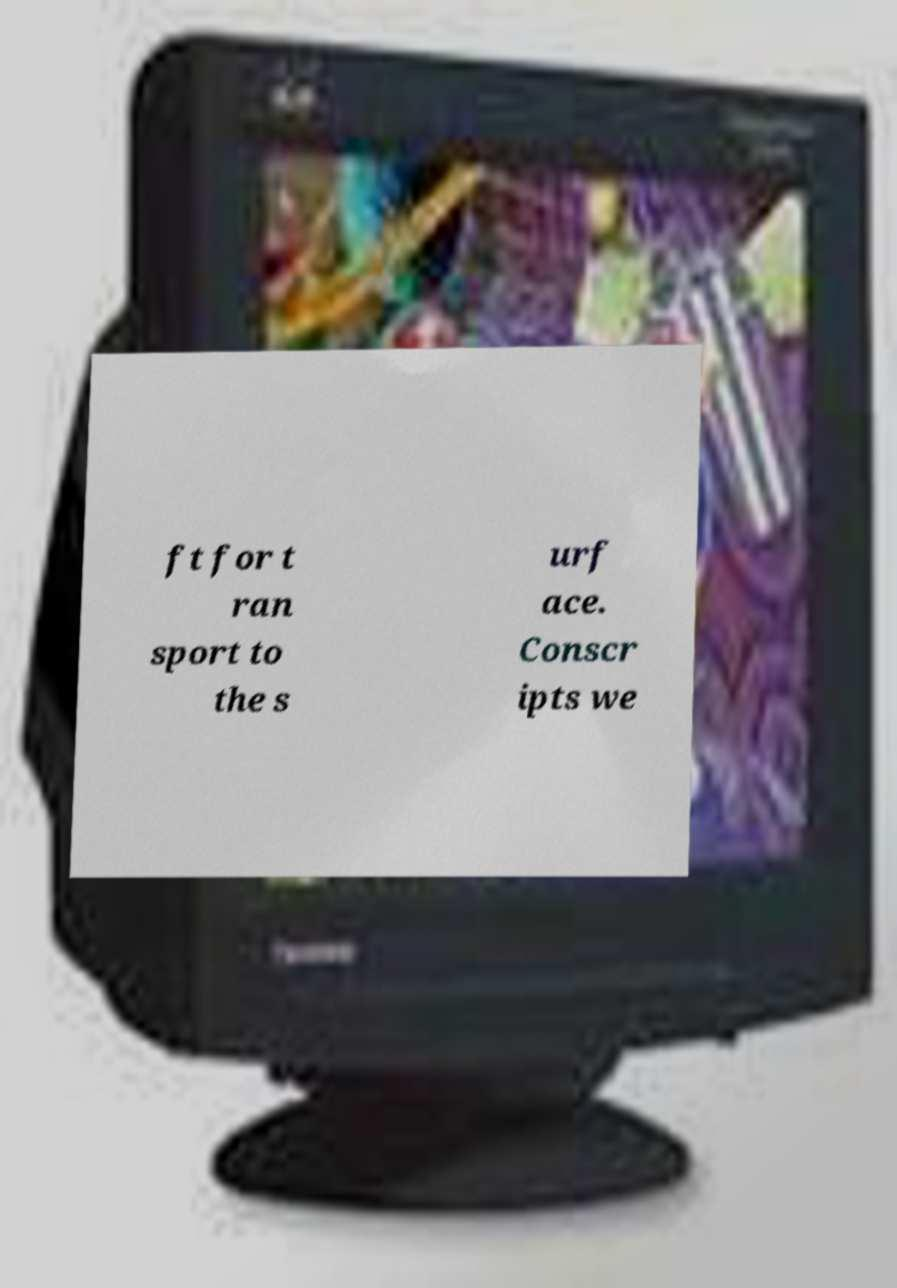What messages or text are displayed in this image? I need them in a readable, typed format. ft for t ran sport to the s urf ace. Conscr ipts we 